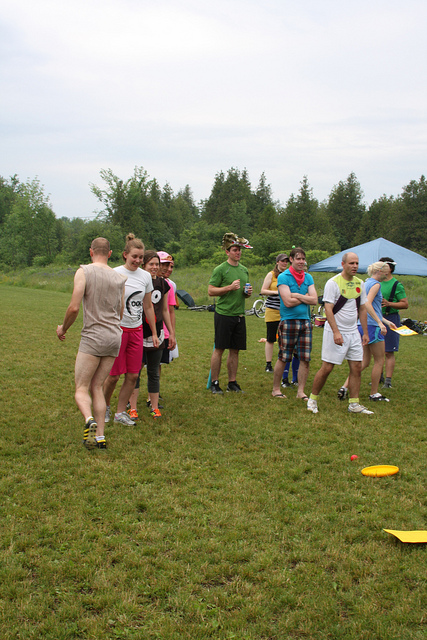What might the people be discussing in this image? The group could be discussing strategies for their frisbee game, sharing stories about past events, or simply catching up with one another if they haven't met in a while. They might also be planning the next activity for the day, whether it's setting up a barbecue, organizing more games, or exploring the nearby forested area. What if some of the group members are professional frisbee players? How would their conversation differ? If some group members are professional frisbee players, their conversation might center around advanced techniques, strategies, and tips to improve their game. They could be exchanging experiences from previous tournaments, discussing recent performances, or even planning to practice specific moves or drills during the event. Their expertise would bring a more competitive edge to the discussion, possibly inspiring others to improve their skills. 